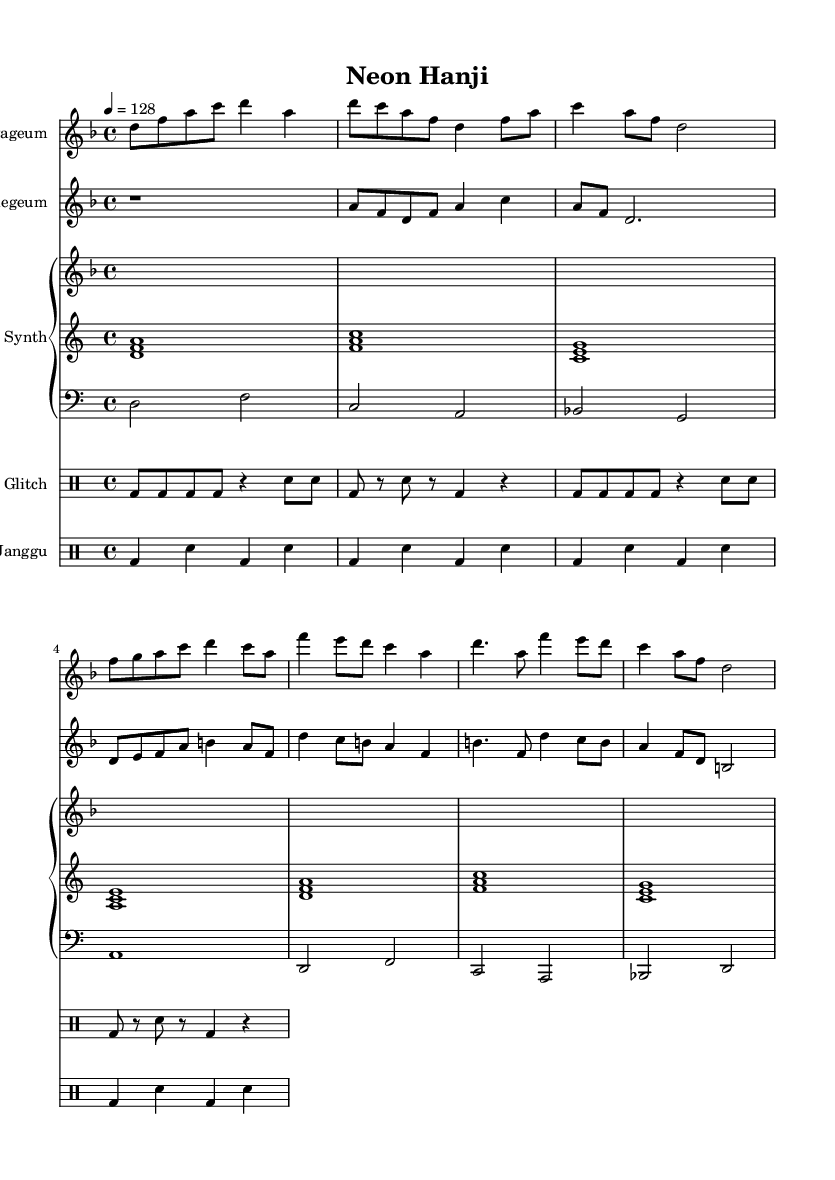What is the key signature of this music? The key signature is indicated by the presence of two flats in the score, specifically representing D minor.
Answer: D minor What is the time signature of this music? The time signature is displayed at the beginning of the score, showing four beats per measure, which is common for many pieces.
Answer: 4/4 What is the tempo marking for this piece? The tempo marking indicates the speed at which the piece should be played, noted as "4 = 128," meaning 128 beats per minute.
Answer: 128 How many measures does the Gayageum part contain? By counting the measures in the Gayageum staff from the beginning to the end, we find that there are eight distinct measures.
Answer: 8 What type of electronic effect is used in this composition? The score includes the term "glitch" specifically indicating the use of glitch effects in one of the drum parts, combining electronic sounds with traditional rhythms.
Answer: Glitch Which traditional Korean instrument is represented as the fourth staff from the top? The fourth staff from the top shows the Janggu, which is a traditional Korean drum used in various forms of music.
Answer: Janggu How does the rhythmic pattern of the Janggu compare to the Glitch effects? The Janggu rhythm consistently follows a four-beat pattern while the Glitch effects are syncopated with a mix of shorter notes and rests, illustrating a distinct contrast.
Answer: Syncopated 